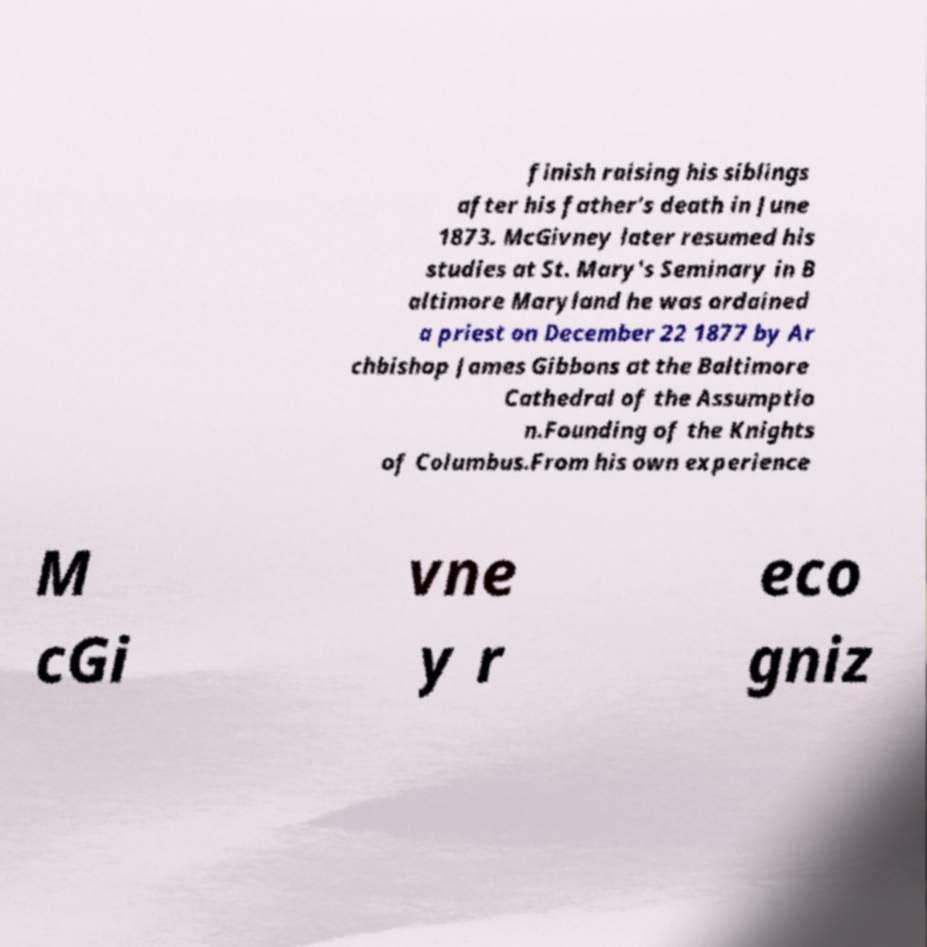Could you extract and type out the text from this image? finish raising his siblings after his father's death in June 1873. McGivney later resumed his studies at St. Mary's Seminary in B altimore Maryland he was ordained a priest on December 22 1877 by Ar chbishop James Gibbons at the Baltimore Cathedral of the Assumptio n.Founding of the Knights of Columbus.From his own experience M cGi vne y r eco gniz 